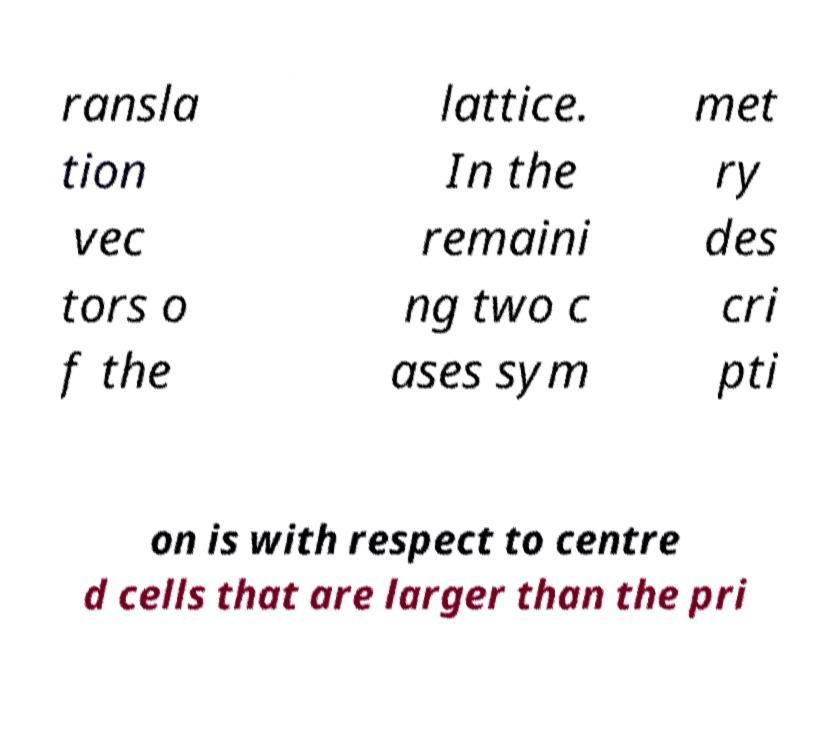Can you accurately transcribe the text from the provided image for me? ransla tion vec tors o f the lattice. In the remaini ng two c ases sym met ry des cri pti on is with respect to centre d cells that are larger than the pri 